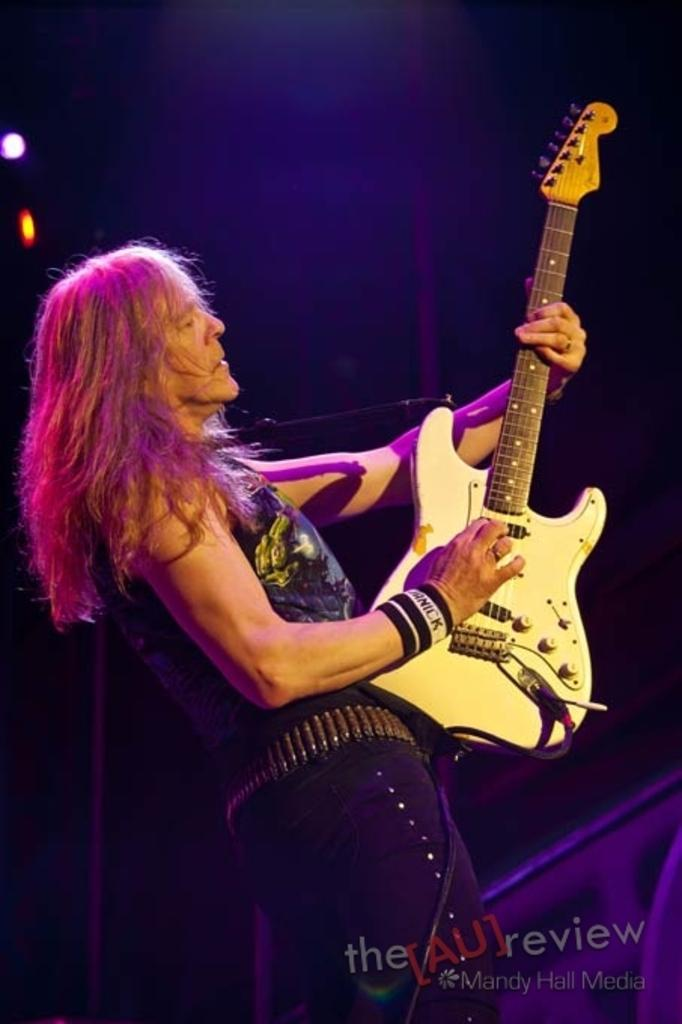What is the man in the image doing? The man is playing a guitar in the image. How is the man positioned in the image? The man is standing in the image. What can be seen in the background of the image? There are focus lights in the background of the image. What is located on the right side of the image? There is a cloth on the right side of the image. What type of coat is the man wearing during his voyage in the image? There is no mention of a coat or voyage in the image; the man is playing a guitar while standing. 